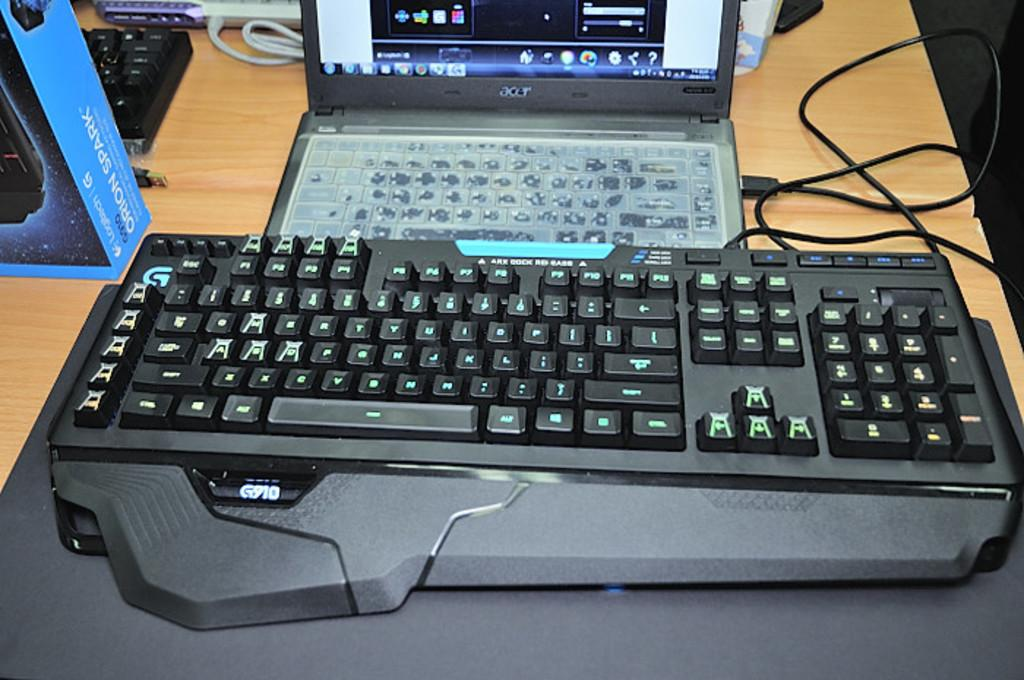<image>
Present a compact description of the photo's key features. an Acer lap top computer attached to a larger G910 keyboard 